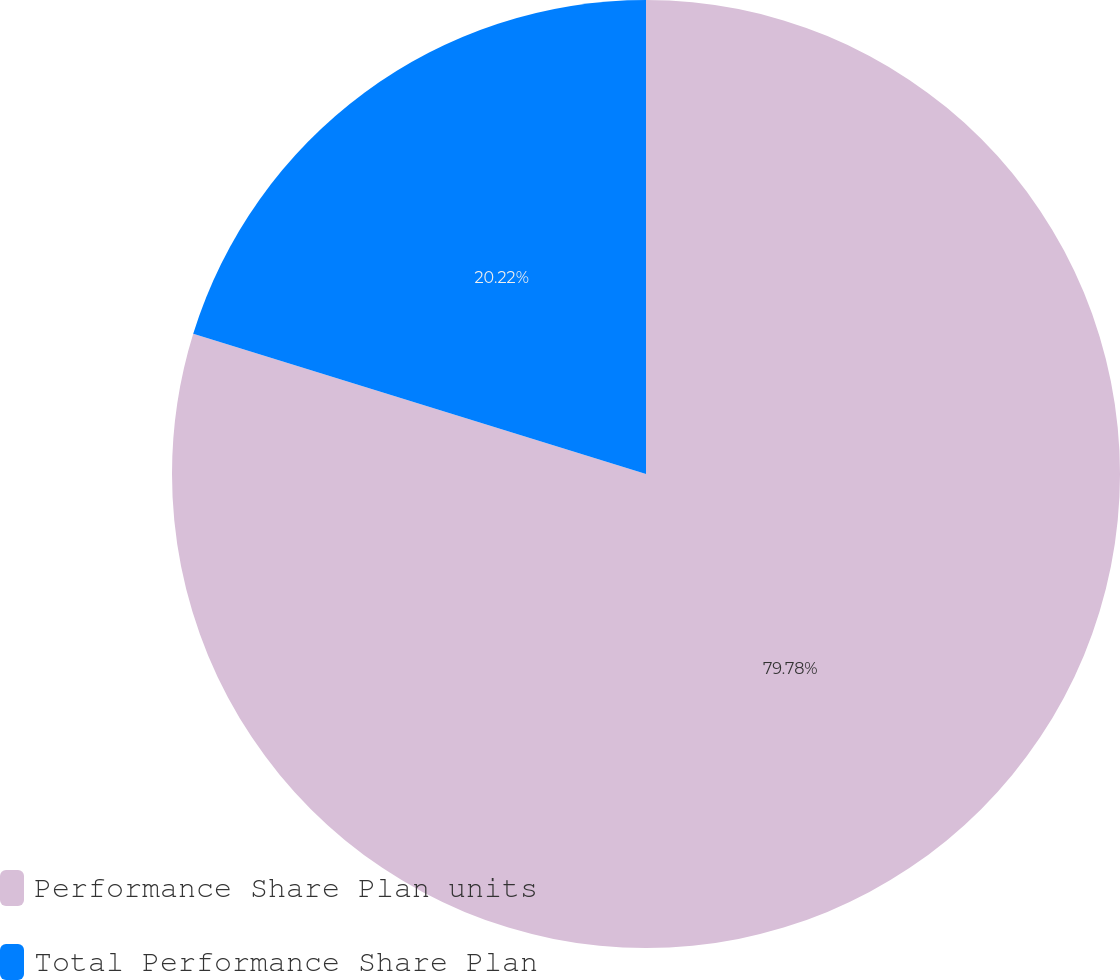Convert chart. <chart><loc_0><loc_0><loc_500><loc_500><pie_chart><fcel>Performance Share Plan units<fcel>Total Performance Share Plan<nl><fcel>79.78%<fcel>20.22%<nl></chart> 